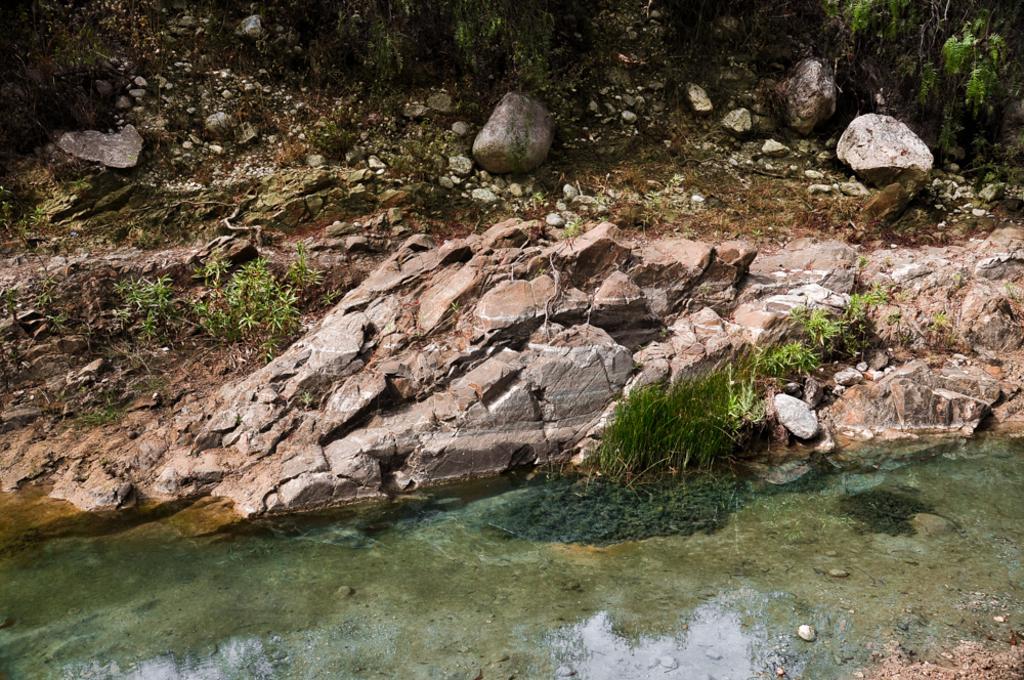How would you summarize this image in a sentence or two? In this image I can see the water, background I can see few stones and I can see plants and trees in green color. 